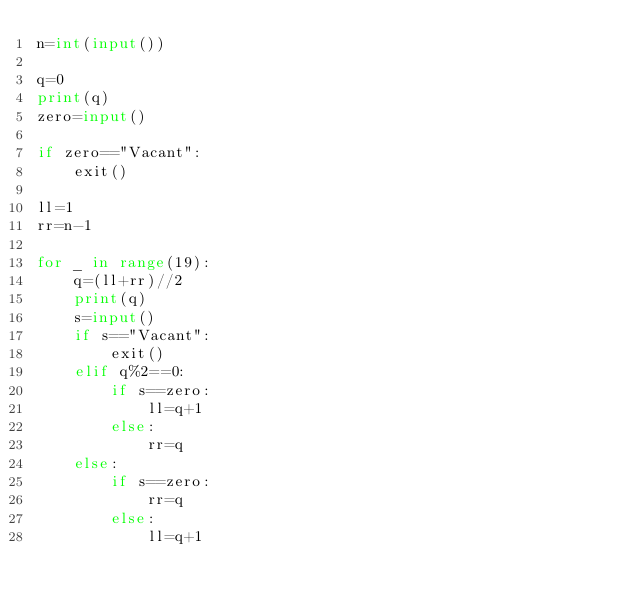<code> <loc_0><loc_0><loc_500><loc_500><_Python_>n=int(input())

q=0
print(q)
zero=input()

if zero=="Vacant":
    exit()

ll=1
rr=n-1

for _ in range(19):
    q=(ll+rr)//2
    print(q)
    s=input()
    if s=="Vacant":
        exit()
    elif q%2==0:
        if s==zero:
            ll=q+1
        else:
            rr=q
    else:
        if s==zero:
            rr=q
        else:
            ll=q+1

</code> 